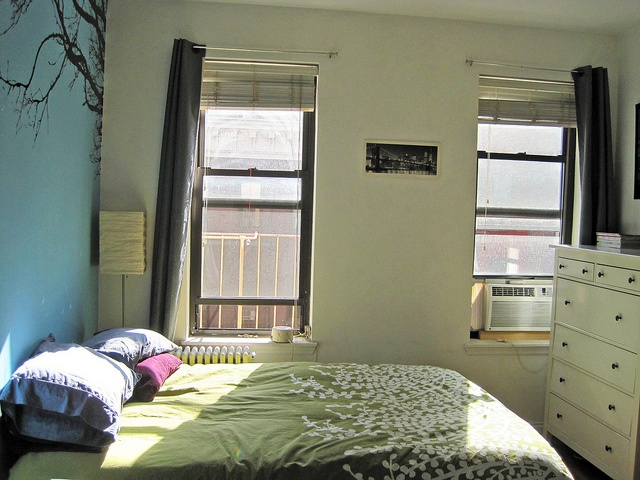Describe the objects in this image and their specific colors. I can see bed in black, gray, ivory, and olive tones, book in black, darkgray, and gray tones, and book in black, darkgray, and brown tones in this image. 